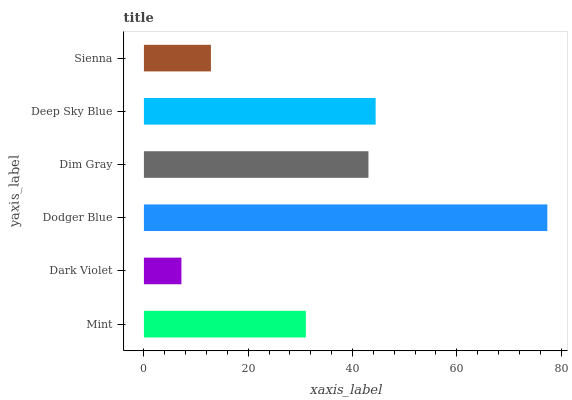Is Dark Violet the minimum?
Answer yes or no. Yes. Is Dodger Blue the maximum?
Answer yes or no. Yes. Is Dodger Blue the minimum?
Answer yes or no. No. Is Dark Violet the maximum?
Answer yes or no. No. Is Dodger Blue greater than Dark Violet?
Answer yes or no. Yes. Is Dark Violet less than Dodger Blue?
Answer yes or no. Yes. Is Dark Violet greater than Dodger Blue?
Answer yes or no. No. Is Dodger Blue less than Dark Violet?
Answer yes or no. No. Is Dim Gray the high median?
Answer yes or no. Yes. Is Mint the low median?
Answer yes or no. Yes. Is Sienna the high median?
Answer yes or no. No. Is Dark Violet the low median?
Answer yes or no. No. 